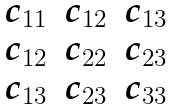<formula> <loc_0><loc_0><loc_500><loc_500>\begin{matrix} c _ { 1 1 } & c _ { 1 2 } & c _ { 1 3 } \\ c _ { 1 2 } & c _ { 2 2 } & c _ { 2 3 } \\ c _ { 1 3 } & c _ { 2 3 } & c _ { 3 3 } \\ \end{matrix}</formula> 